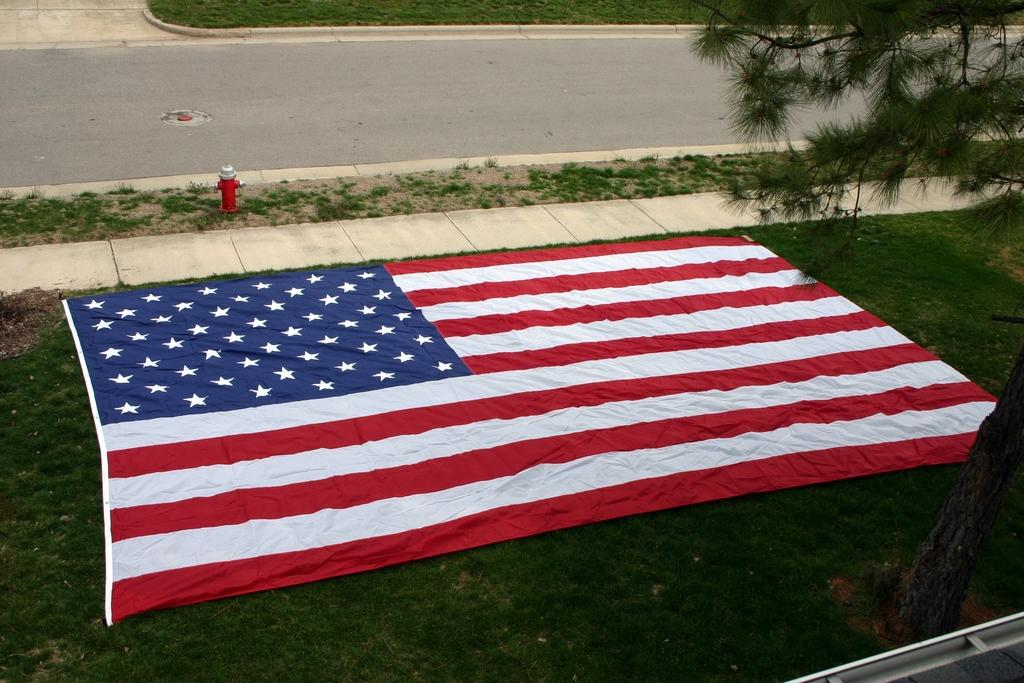What object is on the ground in the image? There is a flag on the ground in the image. What type of natural elements can be seen in the image? There are trees in the image. What type of man-made structure is visible in the image? There is a road in the image. What type of utility object is present in the image? There is a hydrant in the image. What is the price of the cup in the image? There is no cup present in the image, so it is not possible to determine its price. 